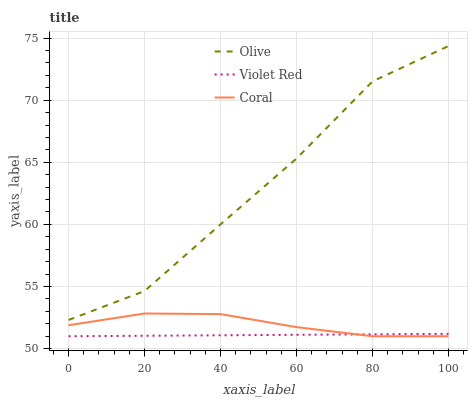Does Violet Red have the minimum area under the curve?
Answer yes or no. Yes. Does Olive have the maximum area under the curve?
Answer yes or no. Yes. Does Coral have the minimum area under the curve?
Answer yes or no. No. Does Coral have the maximum area under the curve?
Answer yes or no. No. Is Violet Red the smoothest?
Answer yes or no. Yes. Is Olive the roughest?
Answer yes or no. Yes. Is Coral the smoothest?
Answer yes or no. No. Is Coral the roughest?
Answer yes or no. No. Does Violet Red have the lowest value?
Answer yes or no. Yes. Does Olive have the highest value?
Answer yes or no. Yes. Does Coral have the highest value?
Answer yes or no. No. Is Coral less than Olive?
Answer yes or no. Yes. Is Olive greater than Violet Red?
Answer yes or no. Yes. Does Violet Red intersect Coral?
Answer yes or no. Yes. Is Violet Red less than Coral?
Answer yes or no. No. Is Violet Red greater than Coral?
Answer yes or no. No. Does Coral intersect Olive?
Answer yes or no. No. 